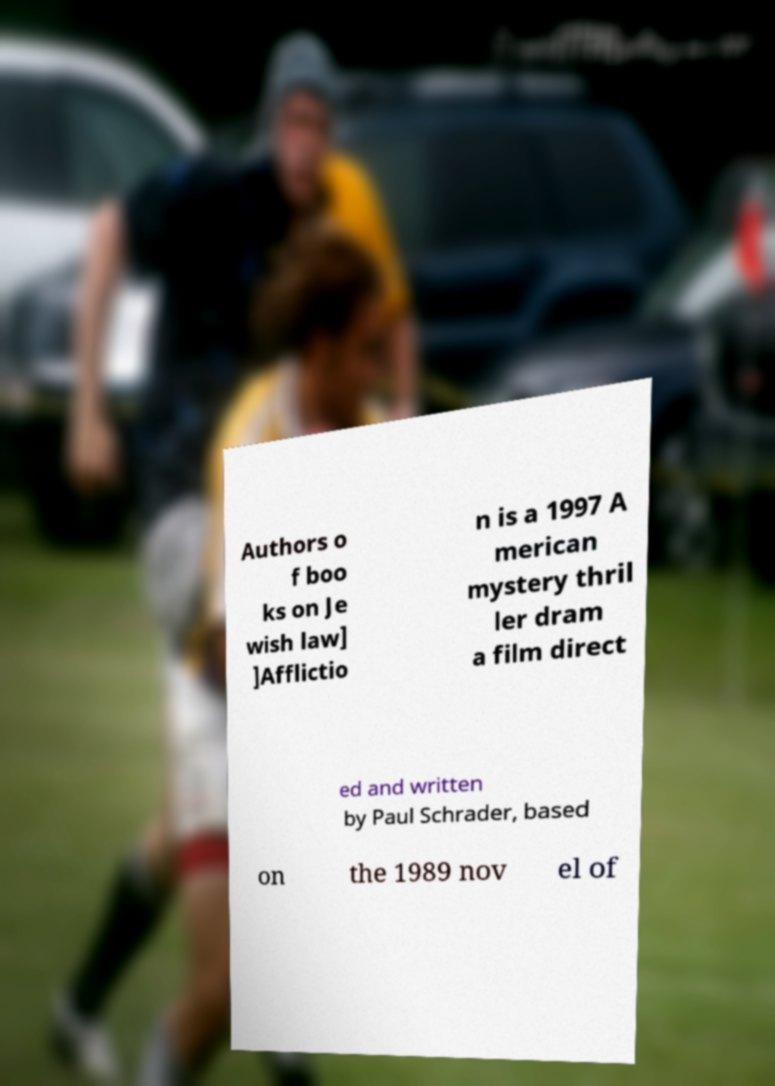Could you extract and type out the text from this image? Authors o f boo ks on Je wish law] ]Afflictio n is a 1997 A merican mystery thril ler dram a film direct ed and written by Paul Schrader, based on the 1989 nov el of 